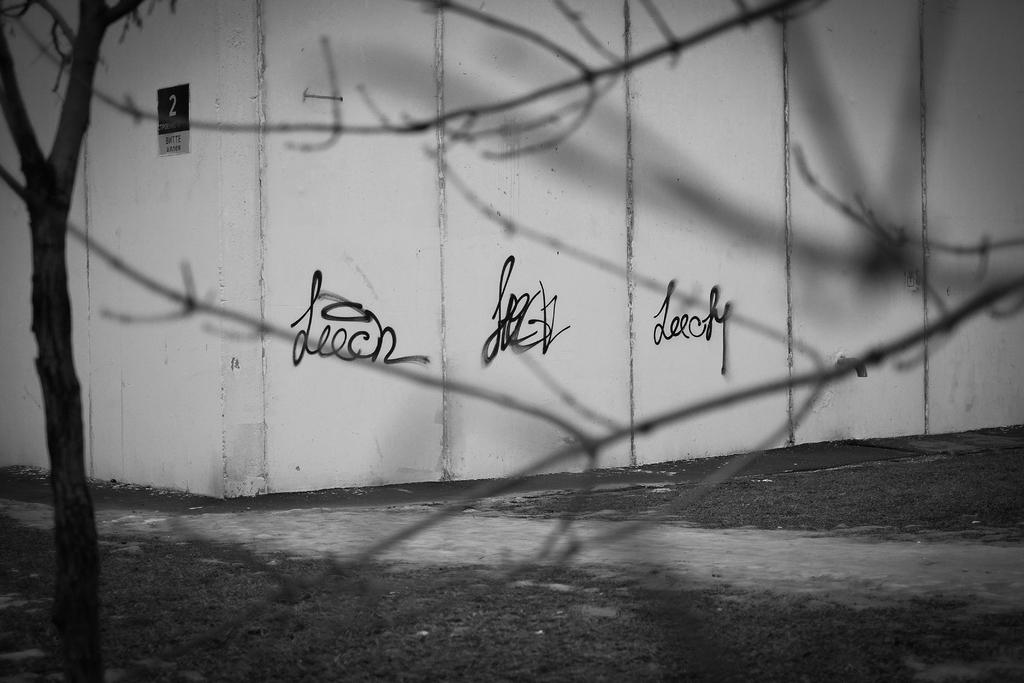What is the color scheme of the image? The image is black and white. What can be seen on the walls in the image? There are writings or drawings on the walls in the image. What type of board is present in the image? There is a number board in the image. What type of natural environment is visible in the image? Trees are visible in the image. What is visible beneath the trees and writings in the image? The ground is visible in the image. How many matches are being used to light the train in the image? There are no matches or trains present in the image. What type of key is being used to unlock the door in the image? There is no door or key present in the image. 